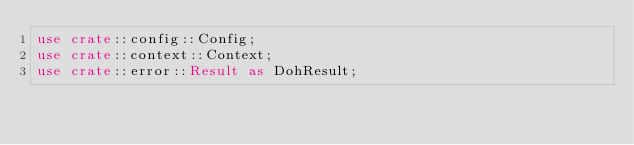Convert code to text. <code><loc_0><loc_0><loc_500><loc_500><_Rust_>use crate::config::Config;
use crate::context::Context;
use crate::error::Result as DohResult;</code> 